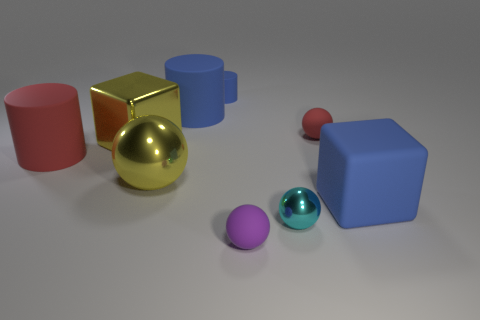Do the big matte cylinder that is on the right side of the yellow metallic ball and the rubber block have the same color?
Offer a very short reply. Yes. There is a large yellow metal ball; are there any small blue matte things in front of it?
Ensure brevity in your answer.  No. The tiny object that is to the left of the cyan object and in front of the large blue rubber cube is what color?
Offer a terse response. Purple. There is a tiny matte object that is the same color as the rubber cube; what is its shape?
Give a very brief answer. Cylinder. How big is the yellow metal thing that is to the right of the yellow object that is behind the big red rubber cylinder?
Ensure brevity in your answer.  Large. How many spheres are large blue metallic things or tiny purple matte objects?
Your answer should be compact. 1. The sphere that is the same size as the rubber cube is what color?
Your answer should be very brief. Yellow. There is a tiny matte thing that is to the left of the matte sphere in front of the small red matte ball; what shape is it?
Provide a short and direct response. Cylinder. There is a matte thing that is in front of the cyan ball; is its size the same as the big yellow ball?
Offer a terse response. No. How many other objects are there of the same material as the red sphere?
Ensure brevity in your answer.  5. 